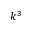<formula> <loc_0><loc_0><loc_500><loc_500>k ^ { 3 }</formula> 